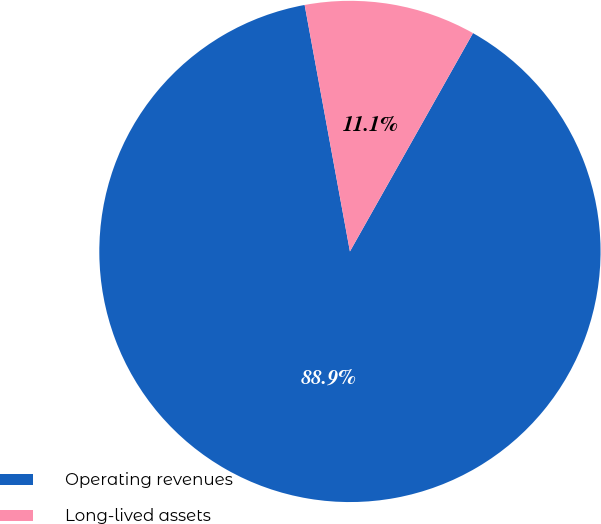Convert chart to OTSL. <chart><loc_0><loc_0><loc_500><loc_500><pie_chart><fcel>Operating revenues<fcel>Long-lived assets<nl><fcel>88.94%<fcel>11.06%<nl></chart> 